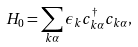Convert formula to latex. <formula><loc_0><loc_0><loc_500><loc_500>H _ { 0 } = \sum _ { k \alpha } \epsilon _ { k } c _ { k \alpha } ^ { \dagger } c _ { k \alpha } ,</formula> 